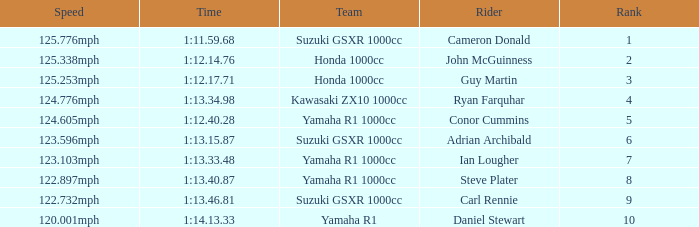What time did team kawasaki zx10 1000cc have? 1:13.34.98. 